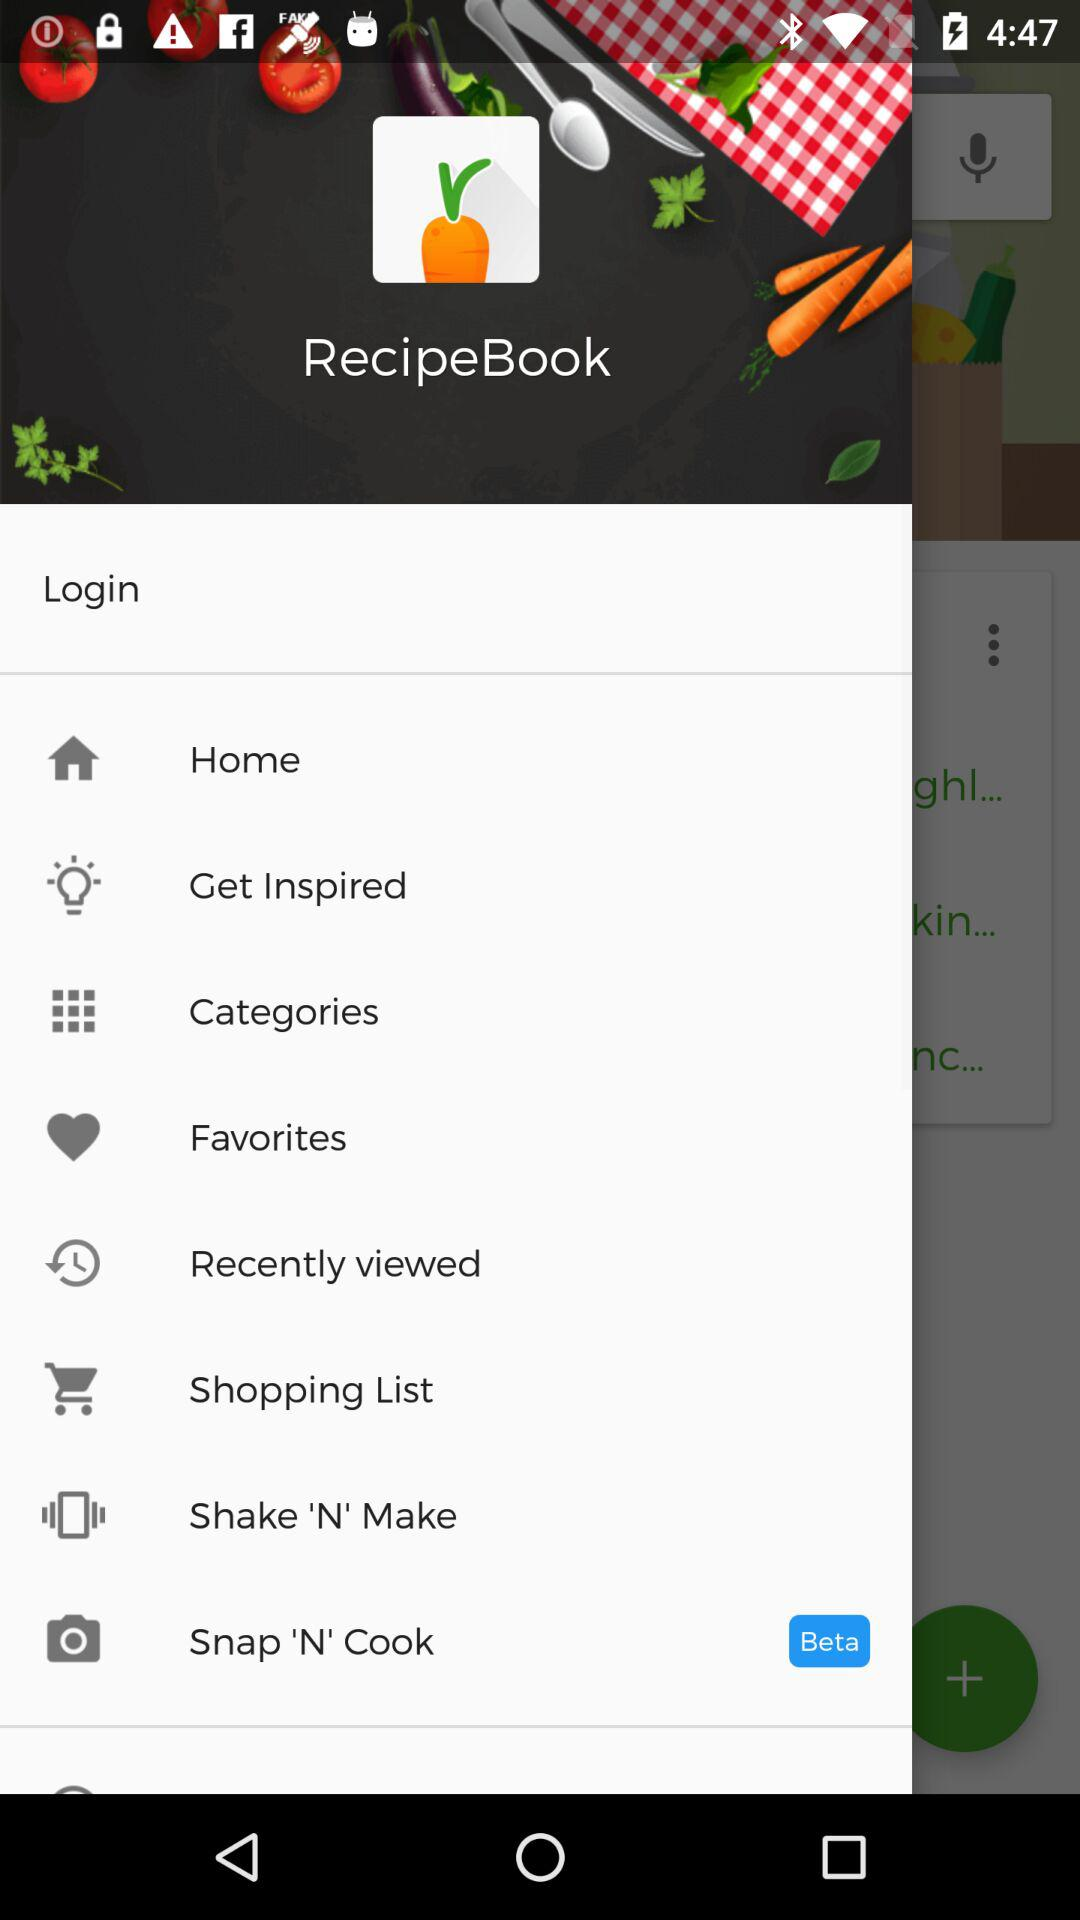What is the name of the application? The name of the application is "RecipeBook". 